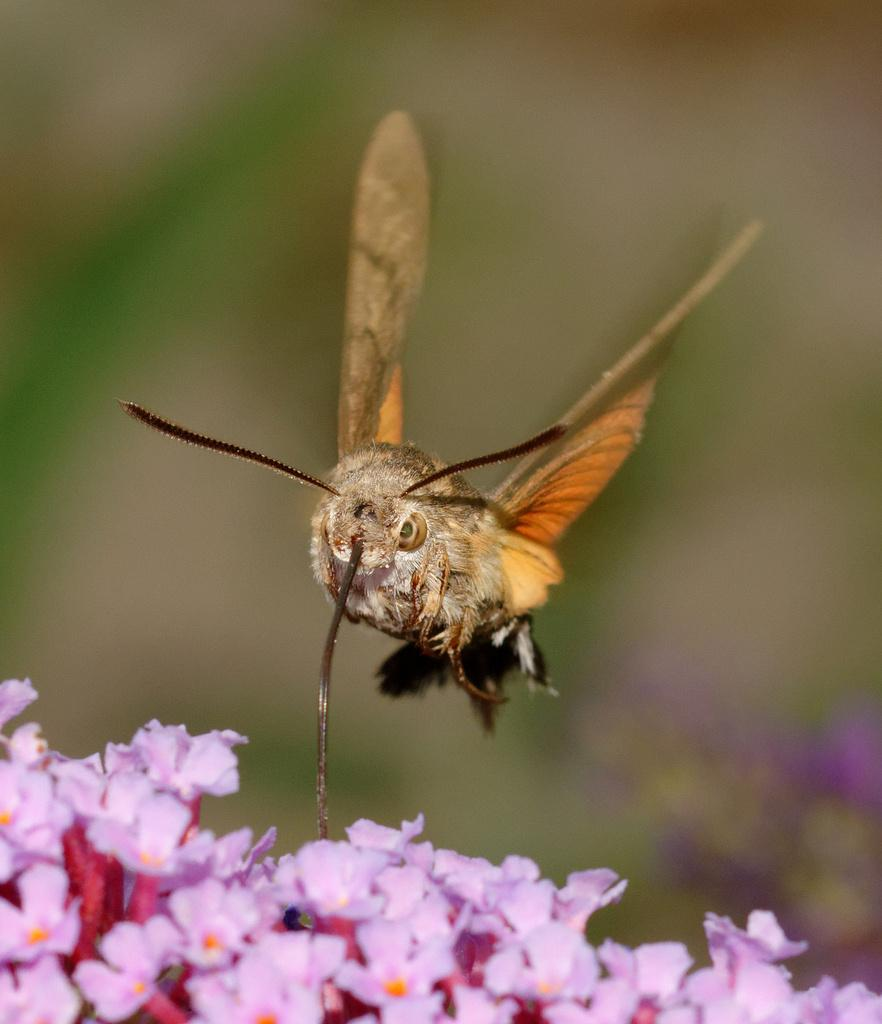What is located at the bottom of the image? There are flowers at the bottom of the image. Is there anything interacting with the flowers? Yes, there is a bee on the flowers. How would you describe the background of the image? The background of the image is blurred. What type of letters can be seen on the bee's wings in the image? There are no letters visible on the bee's wings in the image. What type of jeans is the bee wearing in the image? Bees do not wear jeans, and there is no bee wearing jeans in the image. 